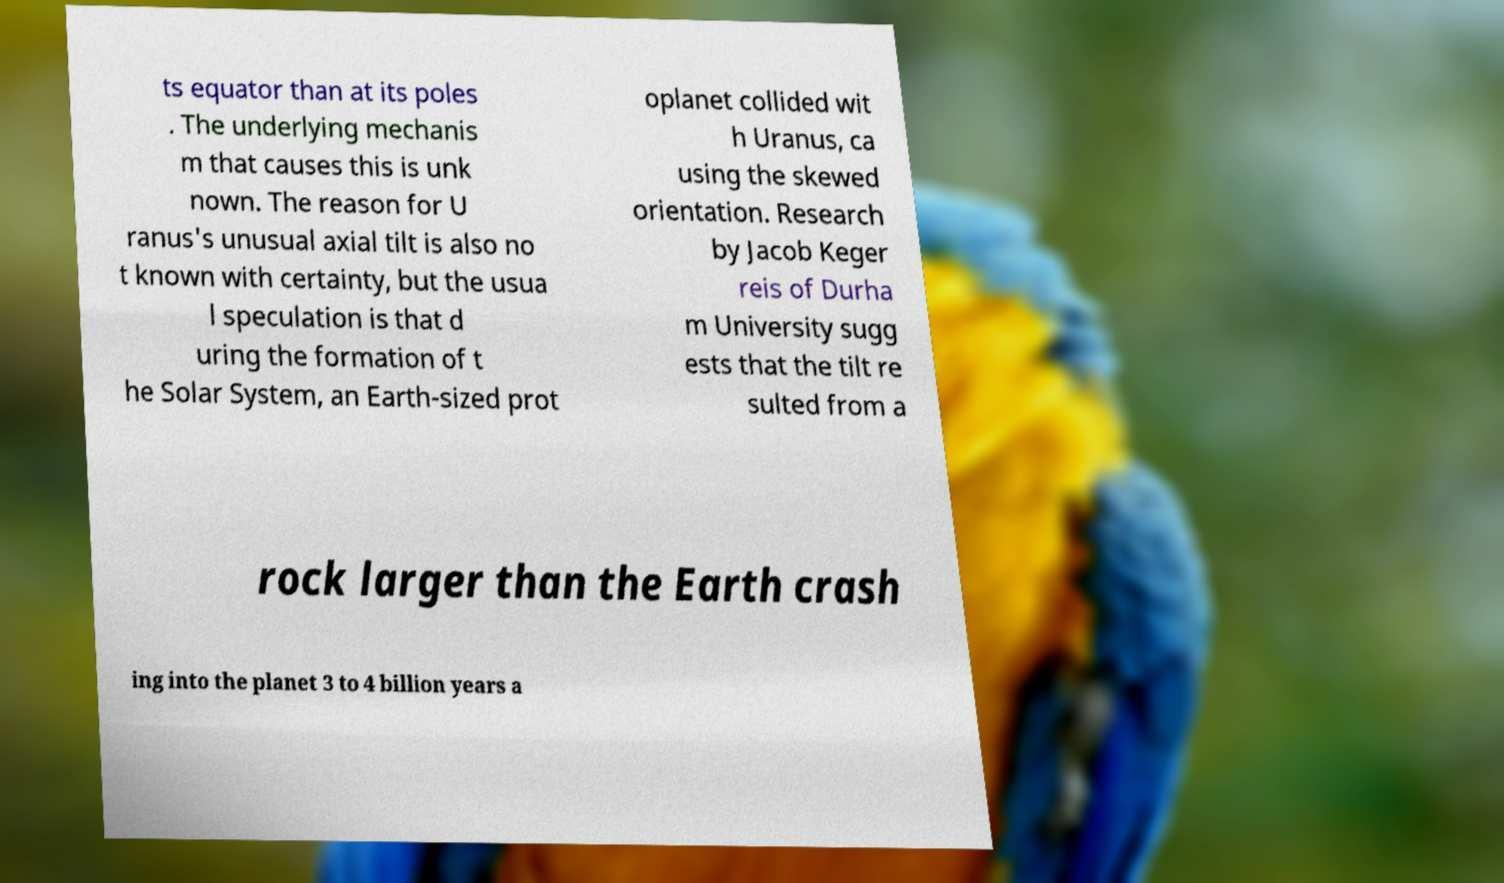What messages or text are displayed in this image? I need them in a readable, typed format. ts equator than at its poles . The underlying mechanis m that causes this is unk nown. The reason for U ranus's unusual axial tilt is also no t known with certainty, but the usua l speculation is that d uring the formation of t he Solar System, an Earth-sized prot oplanet collided wit h Uranus, ca using the skewed orientation. Research by Jacob Keger reis of Durha m University sugg ests that the tilt re sulted from a rock larger than the Earth crash ing into the planet 3 to 4 billion years a 